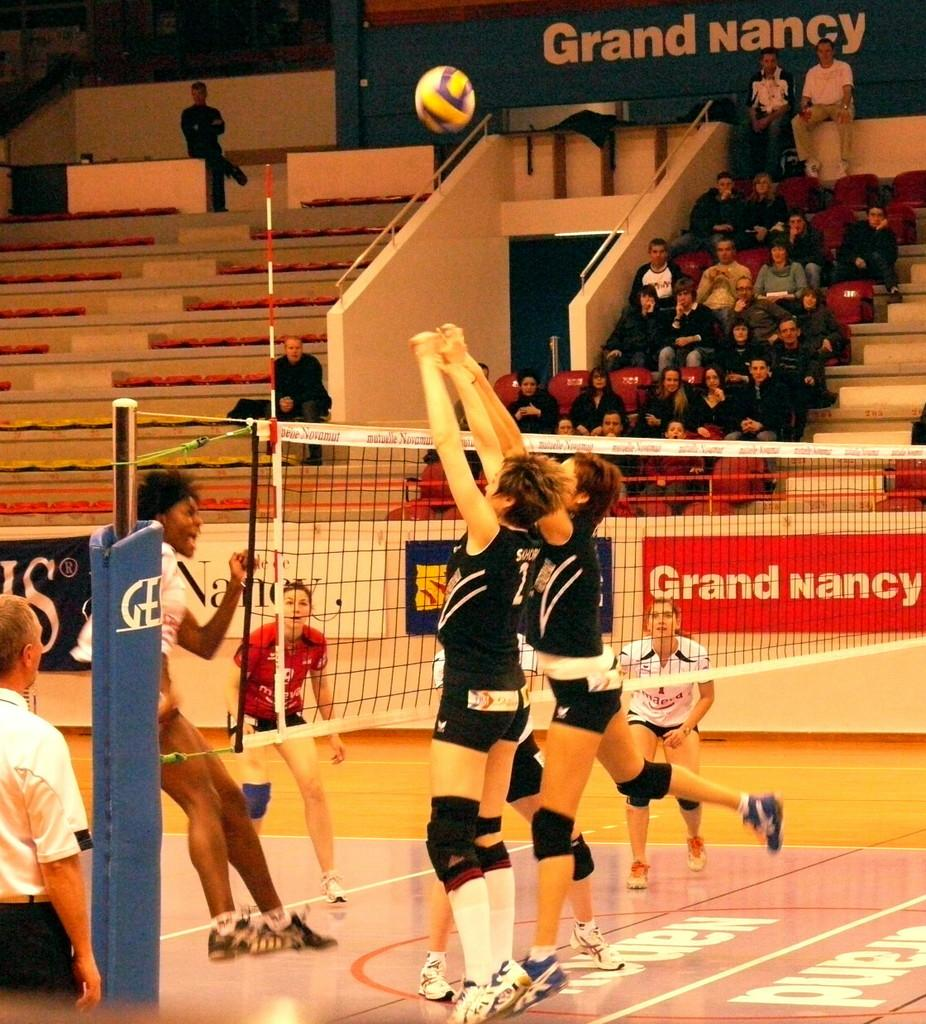<image>
Give a short and clear explanation of the subsequent image. A volleyball player wearing the jersey number 2 jumps up to try to hit the ball. 